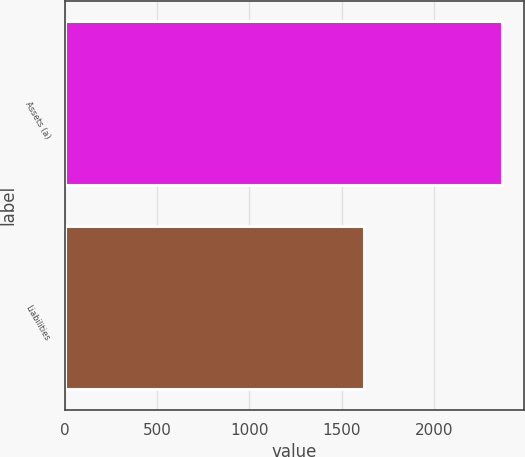Convert chart. <chart><loc_0><loc_0><loc_500><loc_500><bar_chart><fcel>Assets (a)<fcel>Liabilities<nl><fcel>2368<fcel>1622<nl></chart> 